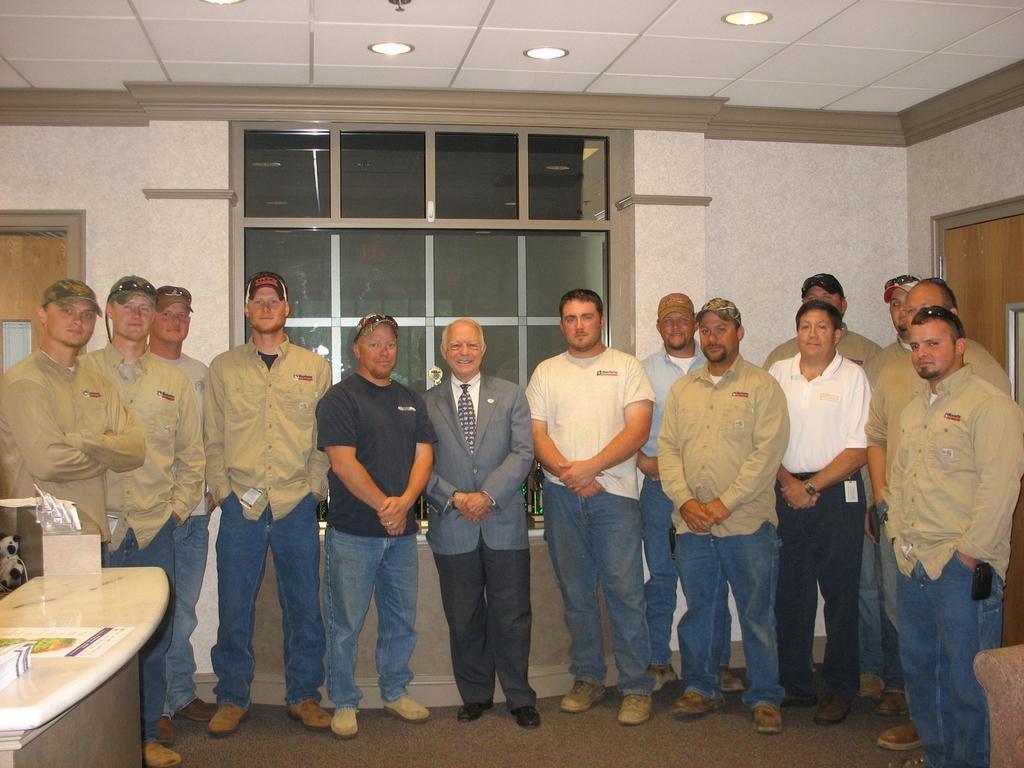In one or two sentences, can you explain what this image depicts? There are a group of people who are standing. This is a wooden table. There is a person who is at center is laughing. 